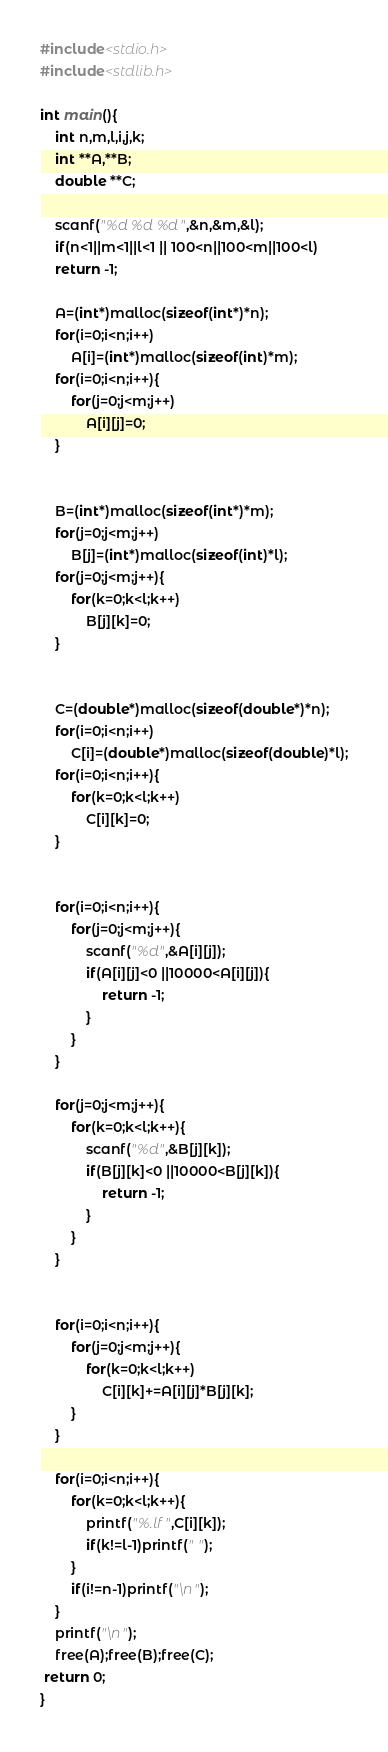Convert code to text. <code><loc_0><loc_0><loc_500><loc_500><_C_>#include<stdio.h>
#include<stdlib.h>

int main(){
    int n,m,l,i,j,k;
    int **A,**B;
    double **C;

    scanf("%d %d %d",&n,&m,&l);
    if(n<1||m<1||l<1 || 100<n||100<m||100<l)
    return -1;

    A=(int*)malloc(sizeof(int*)*n);
    for(i=0;i<n;i++)
        A[i]=(int*)malloc(sizeof(int)*m);
    for(i=0;i<n;i++){
        for(j=0;j<m;j++)
            A[i][j]=0;
    }


    B=(int*)malloc(sizeof(int*)*m);
    for(j=0;j<m;j++)
        B[j]=(int*)malloc(sizeof(int)*l);
    for(j=0;j<m;j++){
        for(k=0;k<l;k++)
            B[j][k]=0;
    }


    C=(double*)malloc(sizeof(double*)*n);
    for(i=0;i<n;i++)
        C[i]=(double*)malloc(sizeof(double)*l);
    for(i=0;i<n;i++){
        for(k=0;k<l;k++)
            C[i][k]=0;
    }


    for(i=0;i<n;i++){
        for(j=0;j<m;j++){
            scanf("%d",&A[i][j]);
            if(A[i][j]<0 ||10000<A[i][j]){
                return -1;
            }
        }
    }

    for(j=0;j<m;j++){
        for(k=0;k<l;k++){
            scanf("%d",&B[j][k]);
            if(B[j][k]<0 ||10000<B[j][k]){
                return -1;
            }
        }
    }


    for(i=0;i<n;i++){
        for(j=0;j<m;j++){
            for(k=0;k<l;k++)
                C[i][k]+=A[i][j]*B[j][k];
        }
    }

    for(i=0;i<n;i++){
        for(k=0;k<l;k++){
            printf("%.lf",C[i][k]);
            if(k!=l-1)printf(" ");
        }
        if(i!=n-1)printf("\n");
    }
    printf("\n");
    free(A);free(B);free(C);
 return 0;
}</code> 